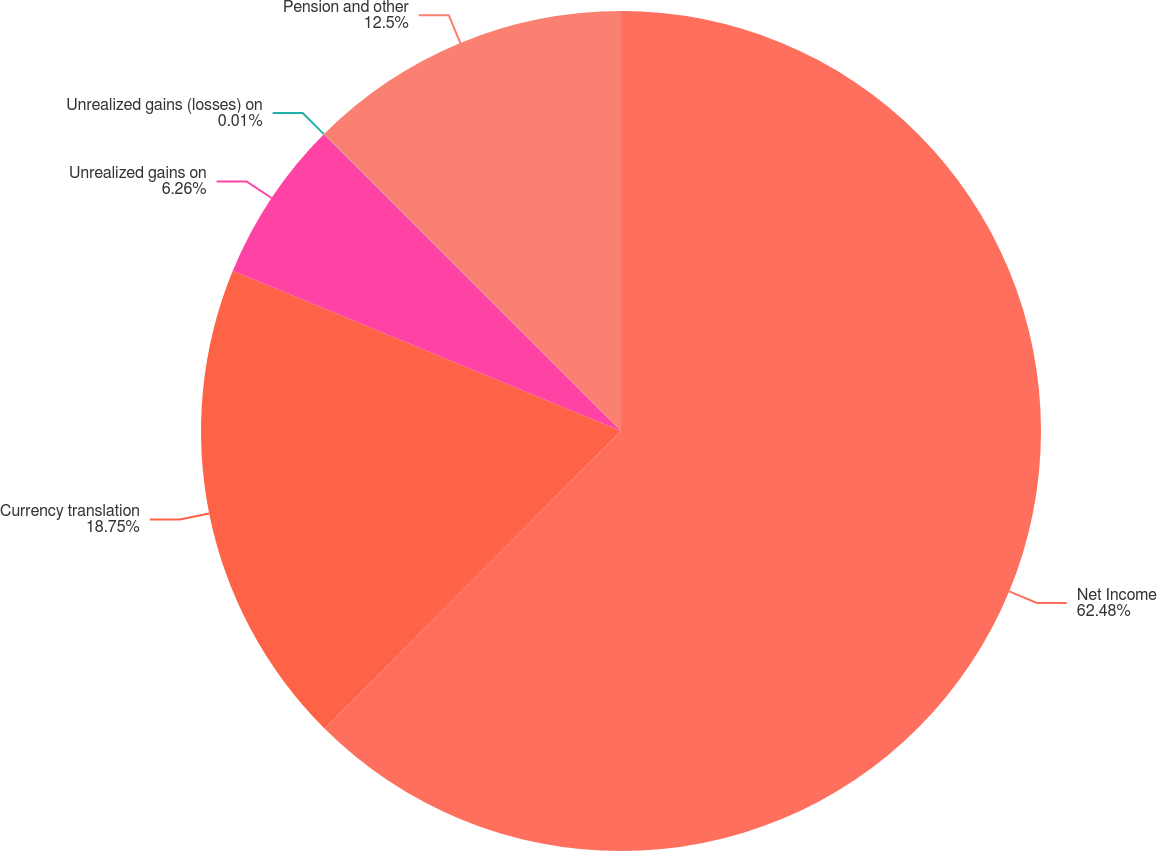<chart> <loc_0><loc_0><loc_500><loc_500><pie_chart><fcel>Net Income<fcel>Currency translation<fcel>Unrealized gains on<fcel>Unrealized gains (losses) on<fcel>Pension and other<nl><fcel>62.47%<fcel>18.75%<fcel>6.26%<fcel>0.01%<fcel>12.5%<nl></chart> 